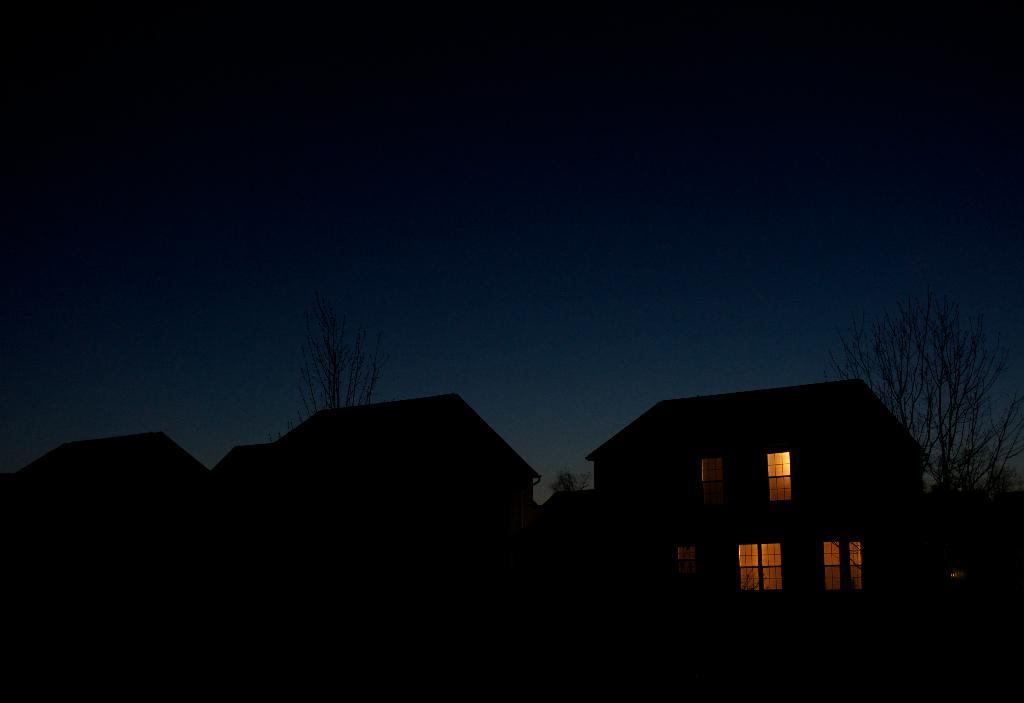What is the overall tone or appearance of the image? The image is dark. What type of structures can be seen in the image? There are buildings with windows in the image. Can you describe the source of light in the image? There is light visible in the image. What type of natural elements are present in the image? There are trees in the image. What part of the natural environment is visible in the image? The sky is visible in the image. What type of baby can be seen playing with a circle in the image? There is no baby or circle present in the image. What is the thing that is causing the light in the image? The source of light in the image is not specified, so it is not possible to determine what is causing it. 